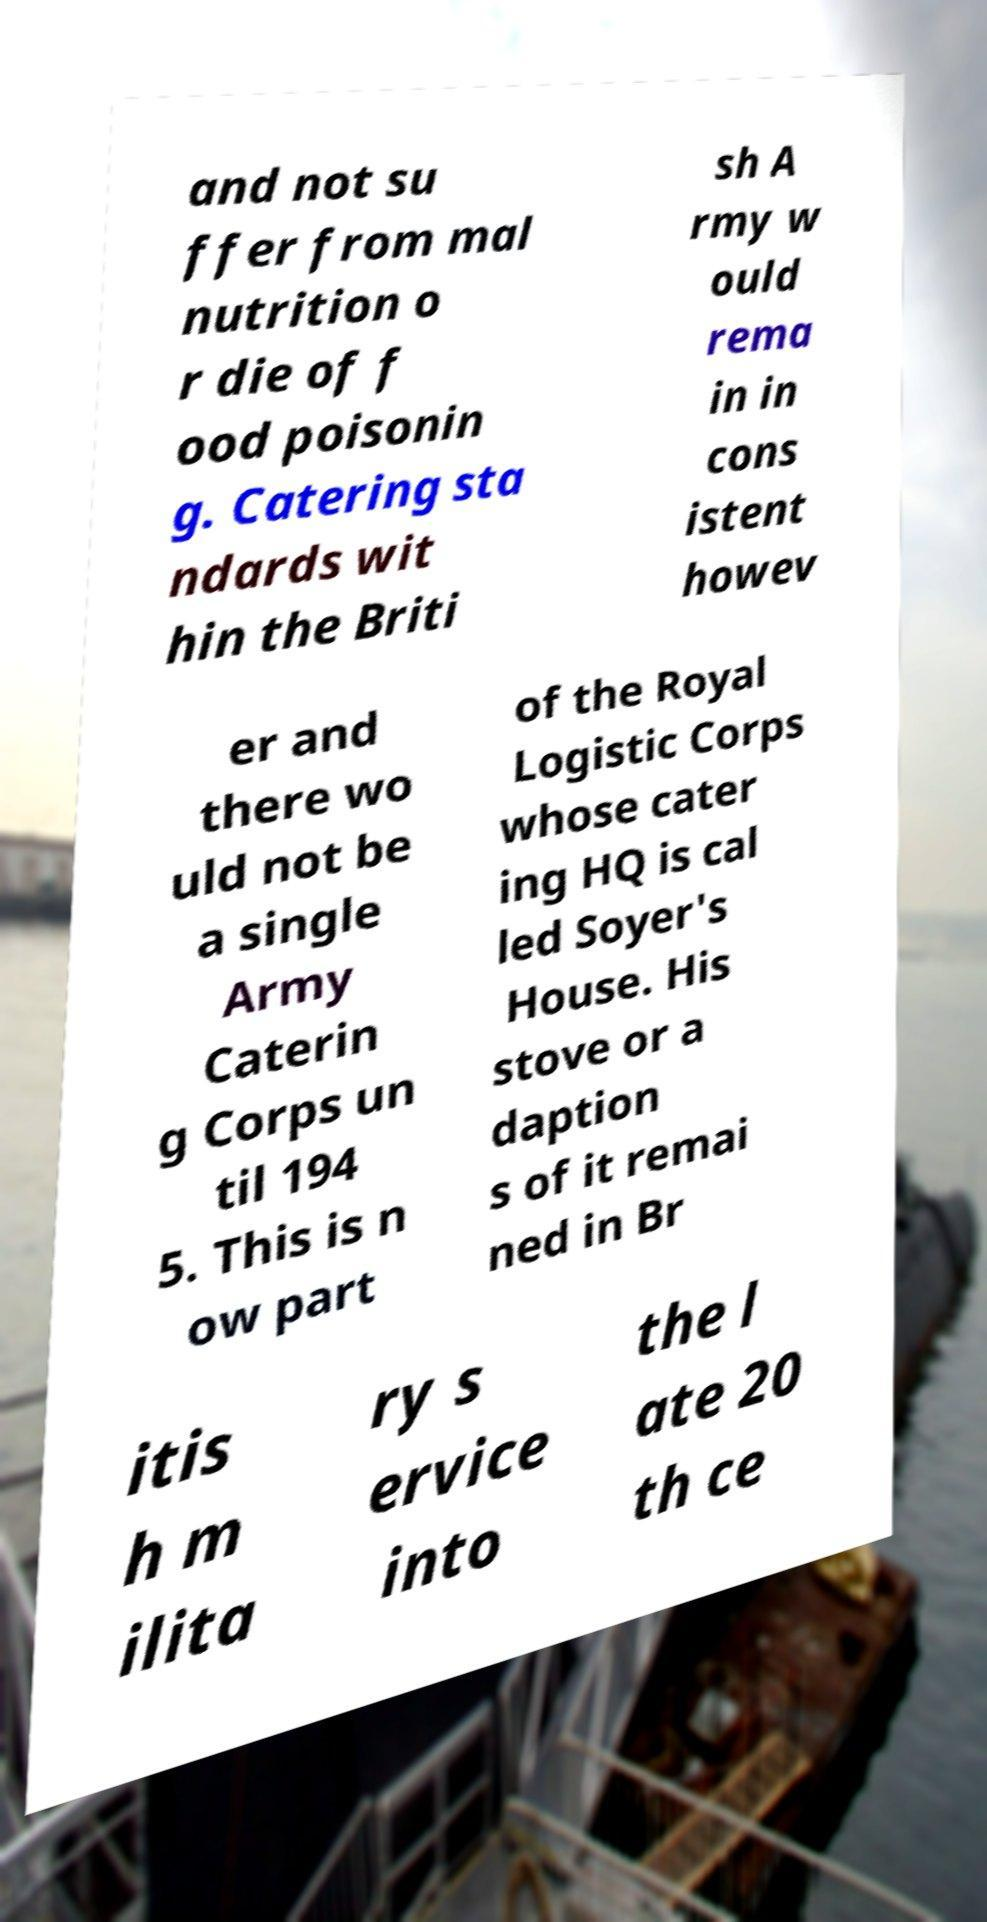Can you accurately transcribe the text from the provided image for me? and not su ffer from mal nutrition o r die of f ood poisonin g. Catering sta ndards wit hin the Briti sh A rmy w ould rema in in cons istent howev er and there wo uld not be a single Army Caterin g Corps un til 194 5. This is n ow part of the Royal Logistic Corps whose cater ing HQ is cal led Soyer's House. His stove or a daption s of it remai ned in Br itis h m ilita ry s ervice into the l ate 20 th ce 